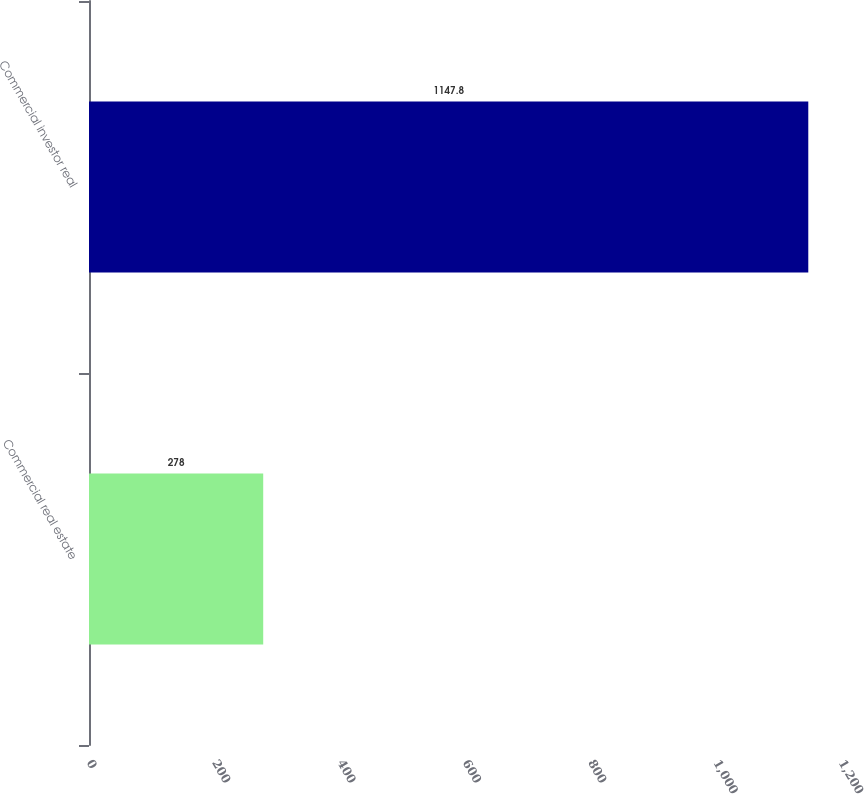Convert chart to OTSL. <chart><loc_0><loc_0><loc_500><loc_500><bar_chart><fcel>Commercial real estate<fcel>Commercial investor real<nl><fcel>278<fcel>1147.8<nl></chart> 